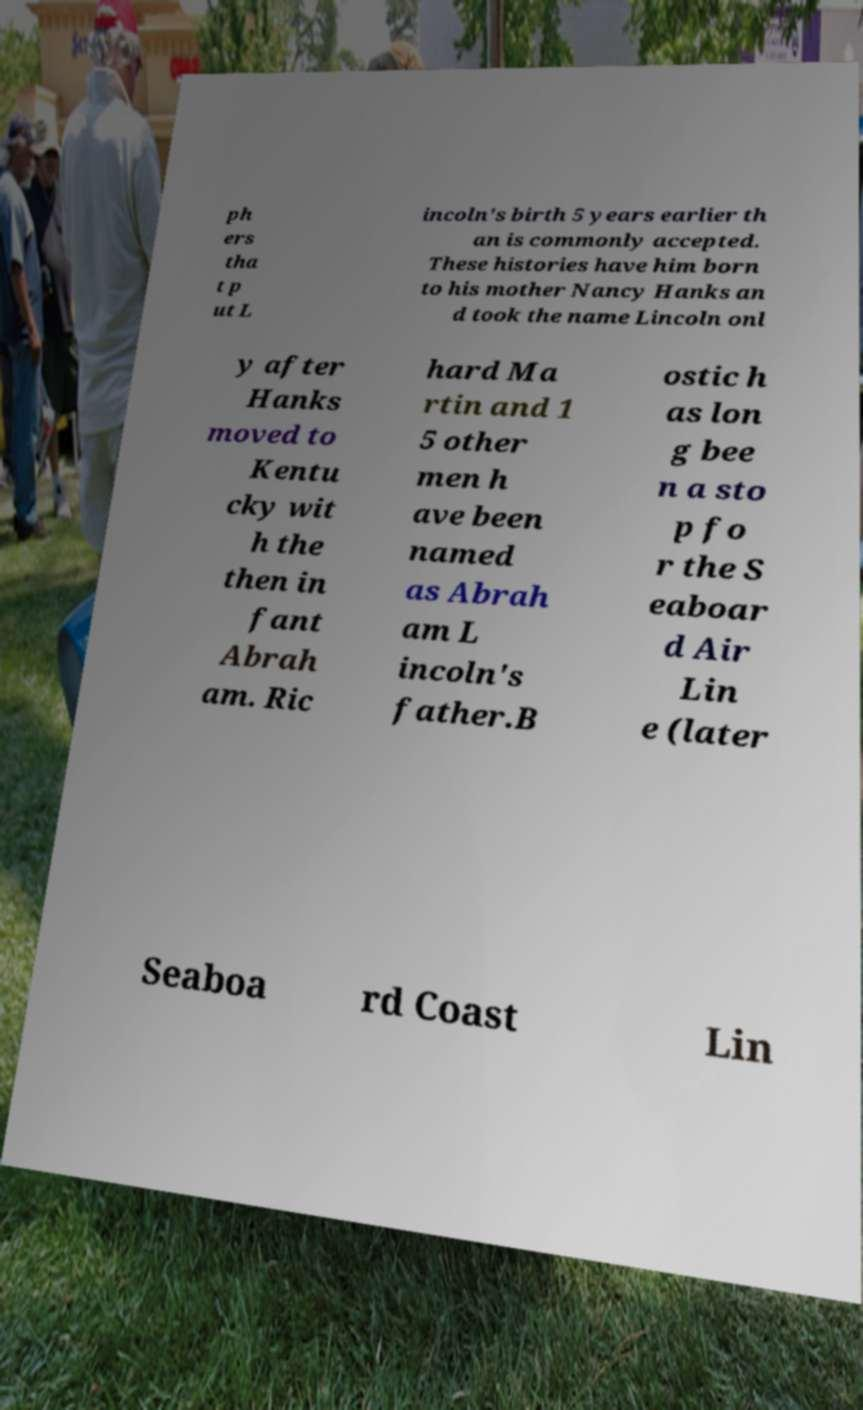What messages or text are displayed in this image? I need them in a readable, typed format. ph ers tha t p ut L incoln's birth 5 years earlier th an is commonly accepted. These histories have him born to his mother Nancy Hanks an d took the name Lincoln onl y after Hanks moved to Kentu cky wit h the then in fant Abrah am. Ric hard Ma rtin and 1 5 other men h ave been named as Abrah am L incoln's father.B ostic h as lon g bee n a sto p fo r the S eaboar d Air Lin e (later Seaboa rd Coast Lin 